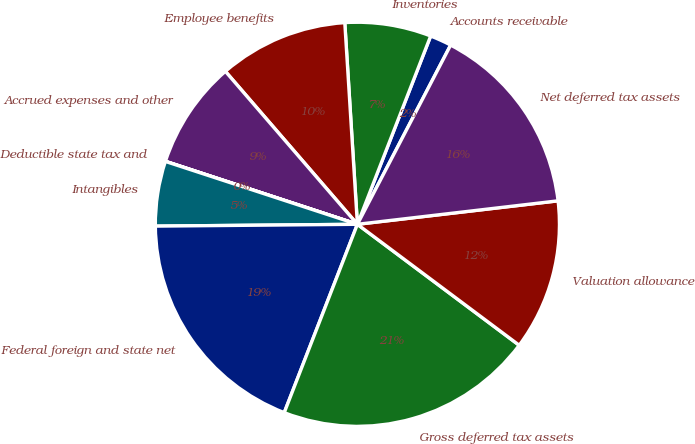Convert chart. <chart><loc_0><loc_0><loc_500><loc_500><pie_chart><fcel>Accounts receivable<fcel>Inventories<fcel>Employee benefits<fcel>Accrued expenses and other<fcel>Deductible state tax and<fcel>Intangibles<fcel>Federal foreign and state net<fcel>Gross deferred tax assets<fcel>Valuation allowance<fcel>Net deferred tax assets<nl><fcel>1.73%<fcel>6.9%<fcel>10.34%<fcel>8.62%<fcel>0.01%<fcel>5.18%<fcel>18.96%<fcel>20.68%<fcel>12.07%<fcel>15.51%<nl></chart> 